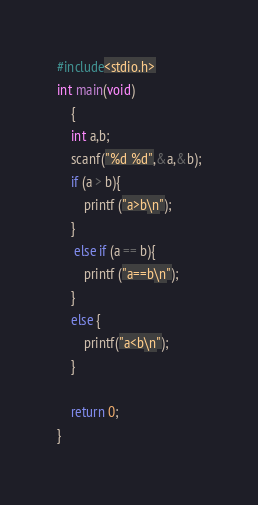<code> <loc_0><loc_0><loc_500><loc_500><_C_>#include<stdio.h>
int main(void)
    {
	int a,b;
	scanf("%d %d",&a,&b);
	if (a > b){
	    printf ("a>b\n");
	}
	 else if (a == b){
		printf ("a==b\n");
	}
	else {
	    printf("a<b\n");
	}
	
	return 0;
}	</code> 